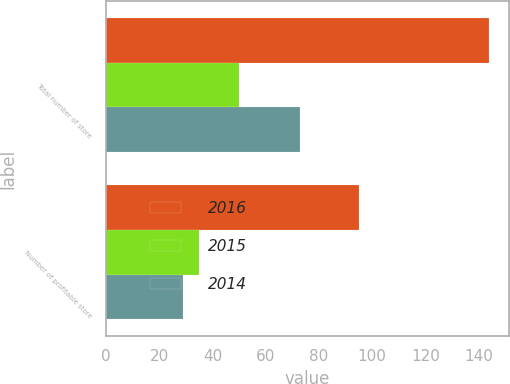Convert chart to OTSL. <chart><loc_0><loc_0><loc_500><loc_500><stacked_bar_chart><ecel><fcel>Total number of store<fcel>Number of profitable store<nl><fcel>2016<fcel>144<fcel>95<nl><fcel>2015<fcel>50<fcel>35<nl><fcel>2014<fcel>73<fcel>29<nl></chart> 